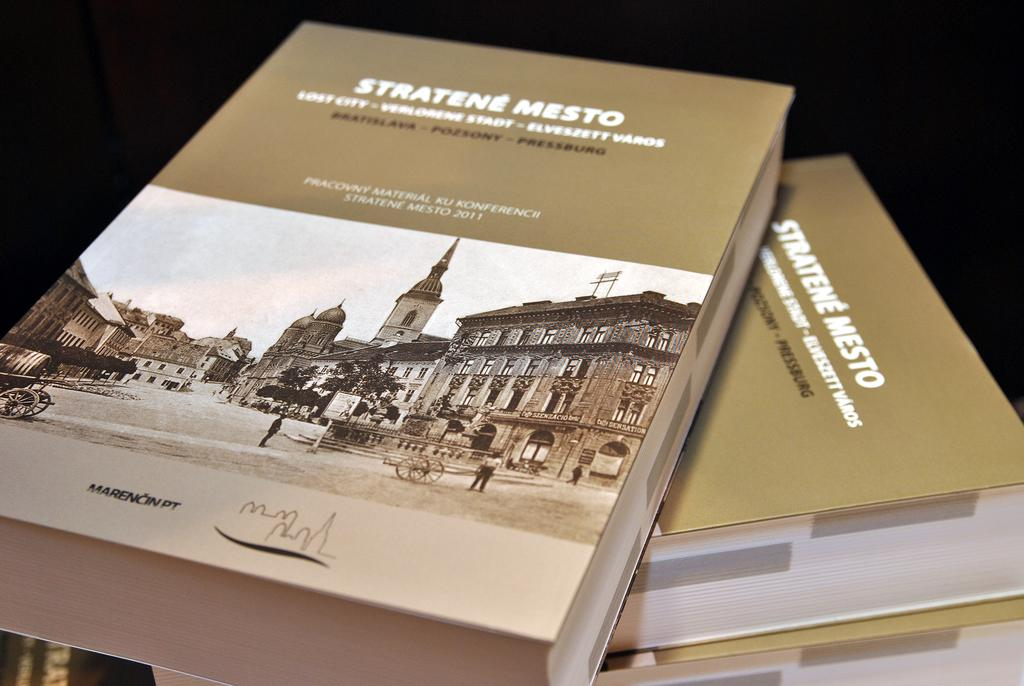<image>
Describe the image concisely. Stratene Mesto books that show a city and some people. 